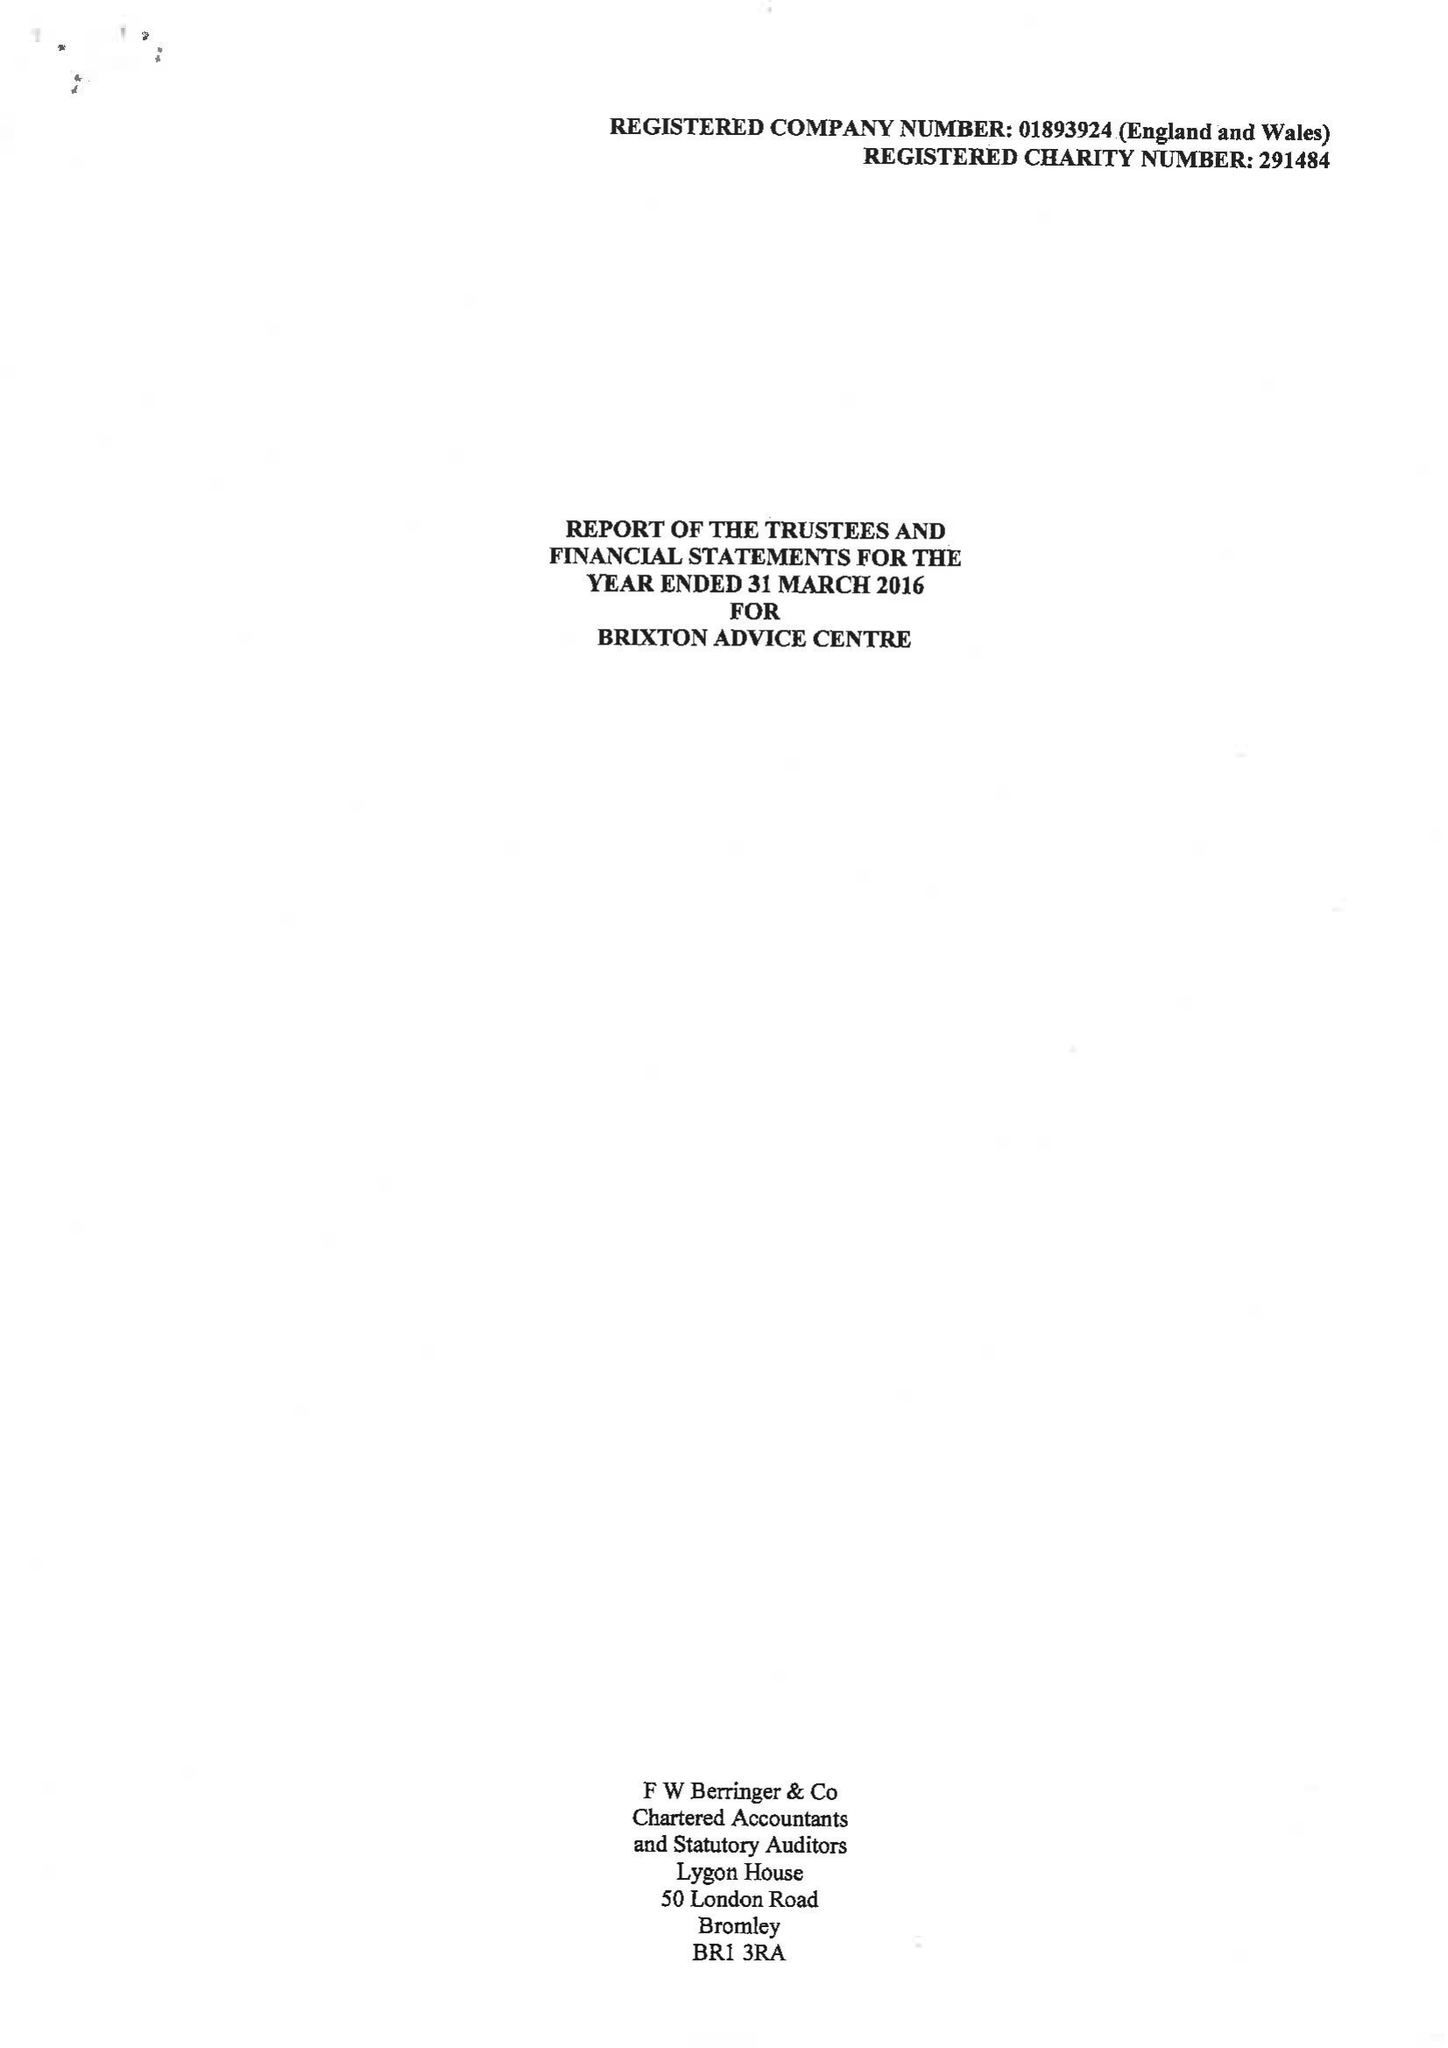What is the value for the report_date?
Answer the question using a single word or phrase. 2016-03-31 